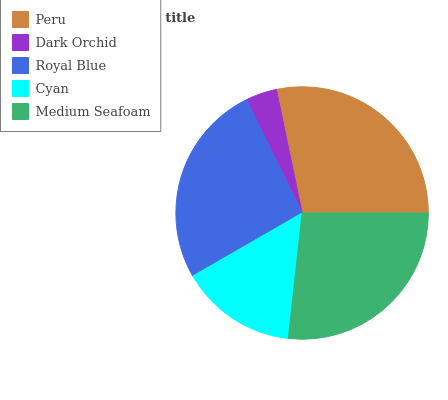Is Dark Orchid the minimum?
Answer yes or no. Yes. Is Peru the maximum?
Answer yes or no. Yes. Is Royal Blue the minimum?
Answer yes or no. No. Is Royal Blue the maximum?
Answer yes or no. No. Is Royal Blue greater than Dark Orchid?
Answer yes or no. Yes. Is Dark Orchid less than Royal Blue?
Answer yes or no. Yes. Is Dark Orchid greater than Royal Blue?
Answer yes or no. No. Is Royal Blue less than Dark Orchid?
Answer yes or no. No. Is Royal Blue the high median?
Answer yes or no. Yes. Is Royal Blue the low median?
Answer yes or no. Yes. Is Dark Orchid the high median?
Answer yes or no. No. Is Dark Orchid the low median?
Answer yes or no. No. 